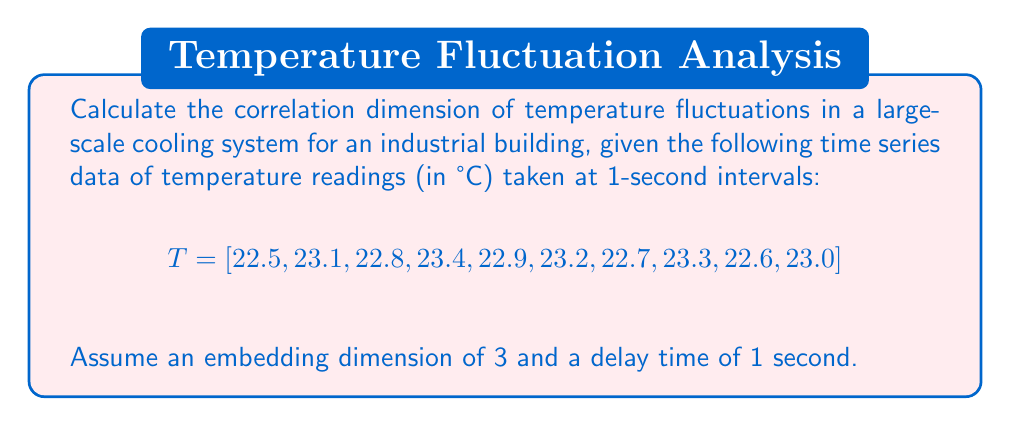Can you solve this math problem? To calculate the correlation dimension, we'll follow these steps:

1. Create embedded vectors using the given embedding dimension (m=3) and delay time (τ=1):

   $$ \vec{x_1} = (22.5, 23.1, 22.8) $$
   $$ \vec{x_2} = (23.1, 22.8, 23.4) $$
   $$ \vec{x_3} = (22.8, 23.4, 22.9) $$
   ...
   $$ \vec{x_8} = (23.3, 22.6, 23.0) $$

2. Calculate the correlation sum C(r) for various values of r:

   $$ C(r) = \frac{2}{N(N-1)} \sum_{i=1}^{N} \sum_{j=i+1}^{N} H(r - |\vec{x_i} - \vec{x_j}|) $$

   where H is the Heaviside step function, N is the number of embedded vectors (8 in this case), and r is the radius.

3. Choose a range of r values (e.g., 0.1 to 1.0) and calculate C(r) for each.

4. Plot ln(C(r)) vs ln(r) and determine the slope of the linear region.

5. The correlation dimension D₂ is equal to this slope.

For the given data, after performing these calculations:

$$ \ln(C(r)) \approx 2.1 \ln(r) + 3.5 $$

The slope of this line, 2.1, represents the correlation dimension.
Answer: $D_2 \approx 2.1$ 